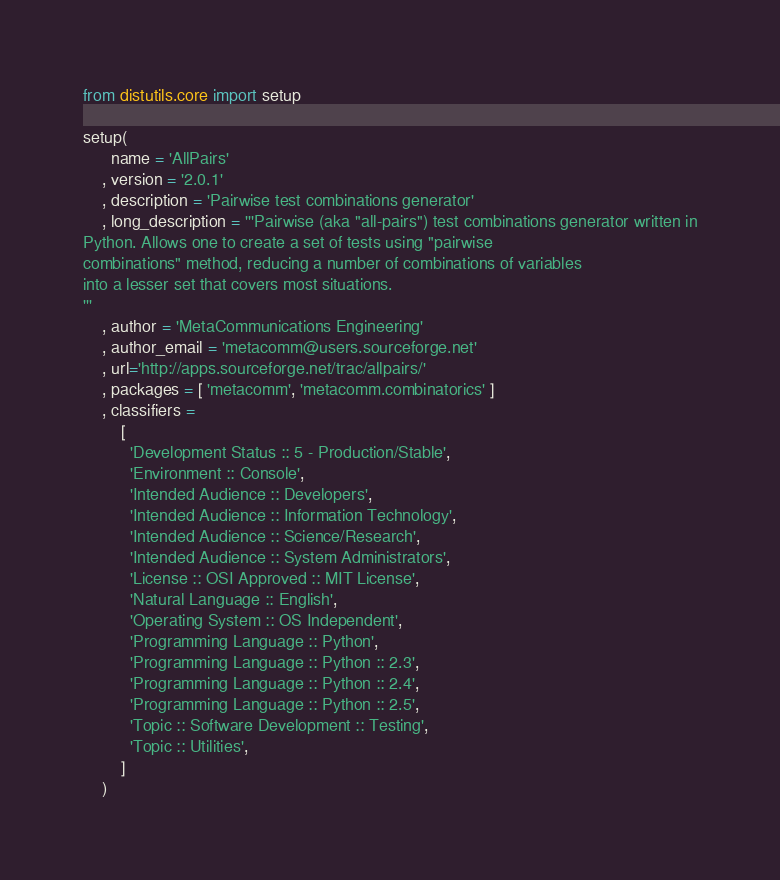Convert code to text. <code><loc_0><loc_0><loc_500><loc_500><_Python_>
from distutils.core import setup

setup(
      name = 'AllPairs'
    , version = '2.0.1'
    , description = 'Pairwise test combinations generator'
    , long_description = '''Pairwise (aka "all-pairs") test combinations generator written in
Python. Allows one to create a set of tests using "pairwise 
combinations" method, reducing a number of combinations of variables
into a lesser set that covers most situations.
'''
    , author = 'MetaCommunications Engineering'
    , author_email = 'metacomm@users.sourceforge.net'
    , url='http://apps.sourceforge.net/trac/allpairs/'
    , packages = [ 'metacomm', 'metacomm.combinatorics' ]
    , classifiers =
        [
          'Development Status :: 5 - Production/Stable',
          'Environment :: Console',
          'Intended Audience :: Developers',
          'Intended Audience :: Information Technology',
          'Intended Audience :: Science/Research',
          'Intended Audience :: System Administrators',
          'License :: OSI Approved :: MIT License',
          'Natural Language :: English',
          'Operating System :: OS Independent',
          'Programming Language :: Python',
          'Programming Language :: Python :: 2.3',
          'Programming Language :: Python :: 2.4',
          'Programming Language :: Python :: 2.5',
          'Topic :: Software Development :: Testing',
          'Topic :: Utilities',
        ]
    )
</code> 